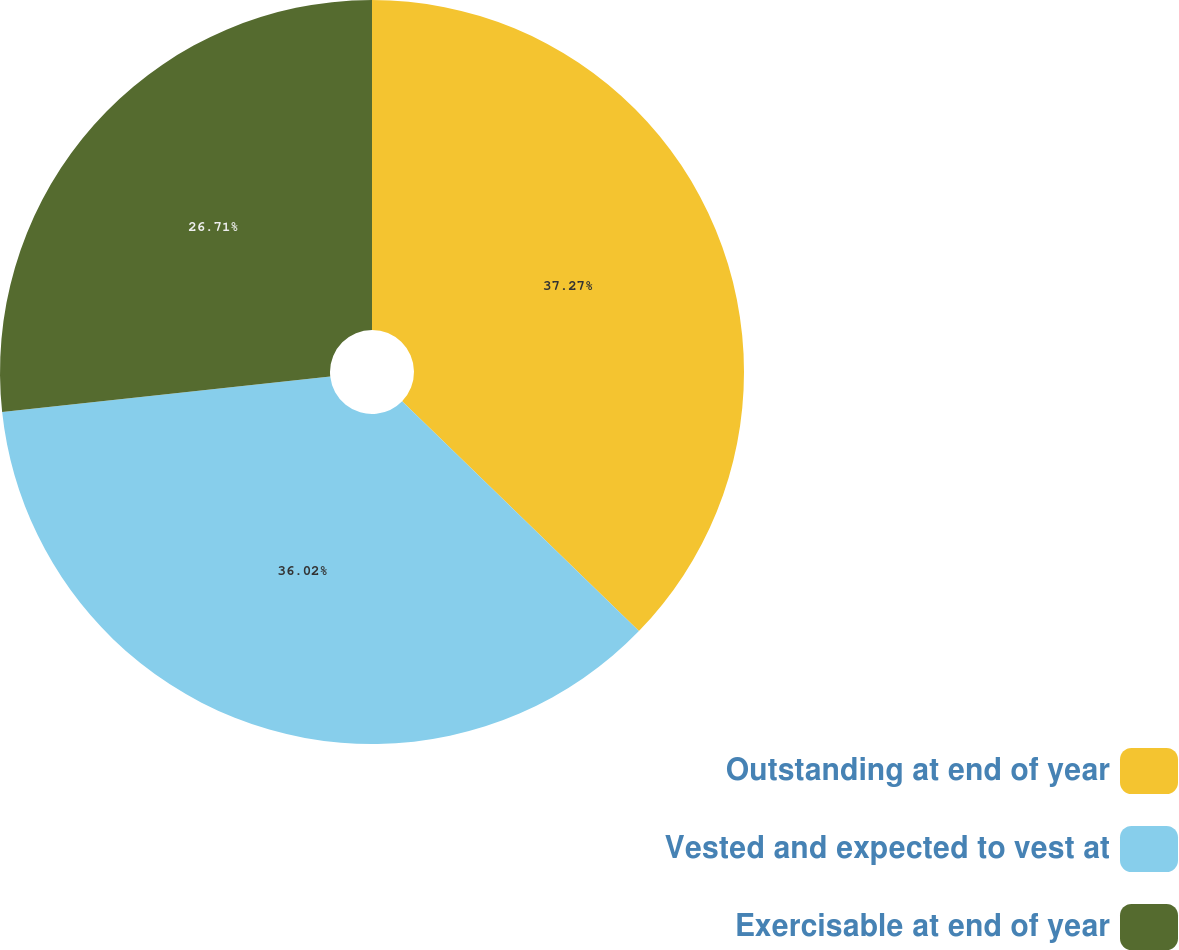<chart> <loc_0><loc_0><loc_500><loc_500><pie_chart><fcel>Outstanding at end of year<fcel>Vested and expected to vest at<fcel>Exercisable at end of year<nl><fcel>37.26%<fcel>36.02%<fcel>26.71%<nl></chart> 